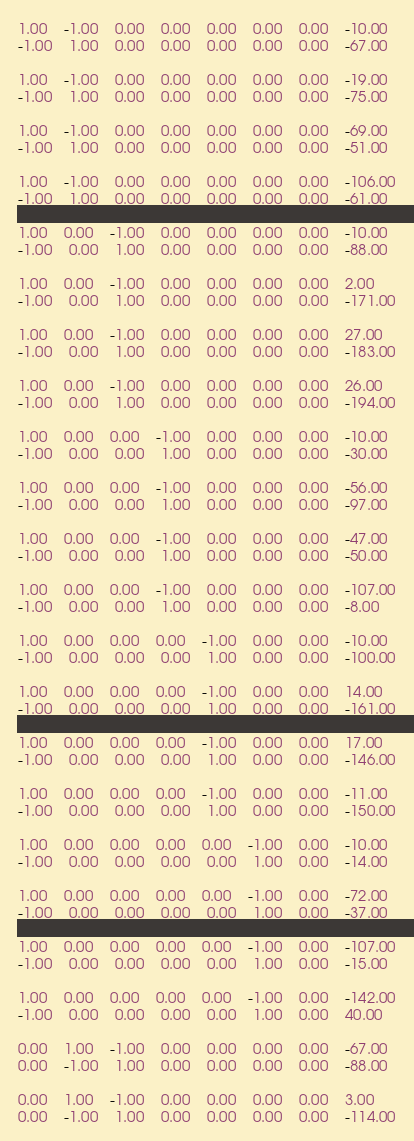<code> <loc_0><loc_0><loc_500><loc_500><_Matlab_>1.00	-1.00	0.00	0.00	0.00	0.00	0.00	-10.00
-1.00	1.00	0.00	0.00	0.00	0.00	0.00	-67.00

1.00	-1.00	0.00	0.00	0.00	0.00	0.00	-19.00
-1.00	1.00	0.00	0.00	0.00	0.00	0.00	-75.00

1.00	-1.00	0.00	0.00	0.00	0.00	0.00	-69.00
-1.00	1.00	0.00	0.00	0.00	0.00	0.00	-51.00

1.00	-1.00	0.00	0.00	0.00	0.00	0.00	-106.00
-1.00	1.00	0.00	0.00	0.00	0.00	0.00	-61.00

1.00	0.00	-1.00	0.00	0.00	0.00	0.00	-10.00
-1.00	0.00	1.00	0.00	0.00	0.00	0.00	-88.00

1.00	0.00	-1.00	0.00	0.00	0.00	0.00	2.00
-1.00	0.00	1.00	0.00	0.00	0.00	0.00	-171.00

1.00	0.00	-1.00	0.00	0.00	0.00	0.00	27.00
-1.00	0.00	1.00	0.00	0.00	0.00	0.00	-183.00

1.00	0.00	-1.00	0.00	0.00	0.00	0.00	26.00
-1.00	0.00	1.00	0.00	0.00	0.00	0.00	-194.00

1.00	0.00	0.00	-1.00	0.00	0.00	0.00	-10.00
-1.00	0.00	0.00	1.00	0.00	0.00	0.00	-30.00

1.00	0.00	0.00	-1.00	0.00	0.00	0.00	-56.00
-1.00	0.00	0.00	1.00	0.00	0.00	0.00	-97.00

1.00	0.00	0.00	-1.00	0.00	0.00	0.00	-47.00
-1.00	0.00	0.00	1.00	0.00	0.00	0.00	-50.00

1.00	0.00	0.00	-1.00	0.00	0.00	0.00	-107.00
-1.00	0.00	0.00	1.00	0.00	0.00	0.00	-8.00

1.00	0.00	0.00	0.00	-1.00	0.00	0.00	-10.00
-1.00	0.00	0.00	0.00	1.00	0.00	0.00	-100.00

1.00	0.00	0.00	0.00	-1.00	0.00	0.00	14.00
-1.00	0.00	0.00	0.00	1.00	0.00	0.00	-161.00

1.00	0.00	0.00	0.00	-1.00	0.00	0.00	17.00
-1.00	0.00	0.00	0.00	1.00	0.00	0.00	-146.00

1.00	0.00	0.00	0.00	-1.00	0.00	0.00	-11.00
-1.00	0.00	0.00	0.00	1.00	0.00	0.00	-150.00

1.00	0.00	0.00	0.00	0.00	-1.00	0.00	-10.00
-1.00	0.00	0.00	0.00	0.00	1.00	0.00	-14.00

1.00	0.00	0.00	0.00	0.00	-1.00	0.00	-72.00
-1.00	0.00	0.00	0.00	0.00	1.00	0.00	-37.00

1.00	0.00	0.00	0.00	0.00	-1.00	0.00	-107.00
-1.00	0.00	0.00	0.00	0.00	1.00	0.00	-15.00

1.00	0.00	0.00	0.00	0.00	-1.00	0.00	-142.00
-1.00	0.00	0.00	0.00	0.00	1.00	0.00	40.00

0.00	1.00	-1.00	0.00	0.00	0.00	0.00	-67.00
0.00	-1.00	1.00	0.00	0.00	0.00	0.00	-88.00

0.00	1.00	-1.00	0.00	0.00	0.00	0.00	3.00
0.00	-1.00	1.00	0.00	0.00	0.00	0.00	-114.00
</code> 